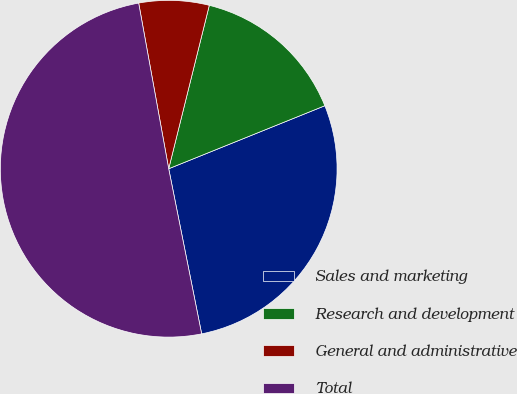<chart> <loc_0><loc_0><loc_500><loc_500><pie_chart><fcel>Sales and marketing<fcel>Research and development<fcel>General and administrative<fcel>Total<nl><fcel>27.97%<fcel>15.02%<fcel>6.73%<fcel>50.28%<nl></chart> 